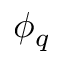<formula> <loc_0><loc_0><loc_500><loc_500>\phi _ { q }</formula> 